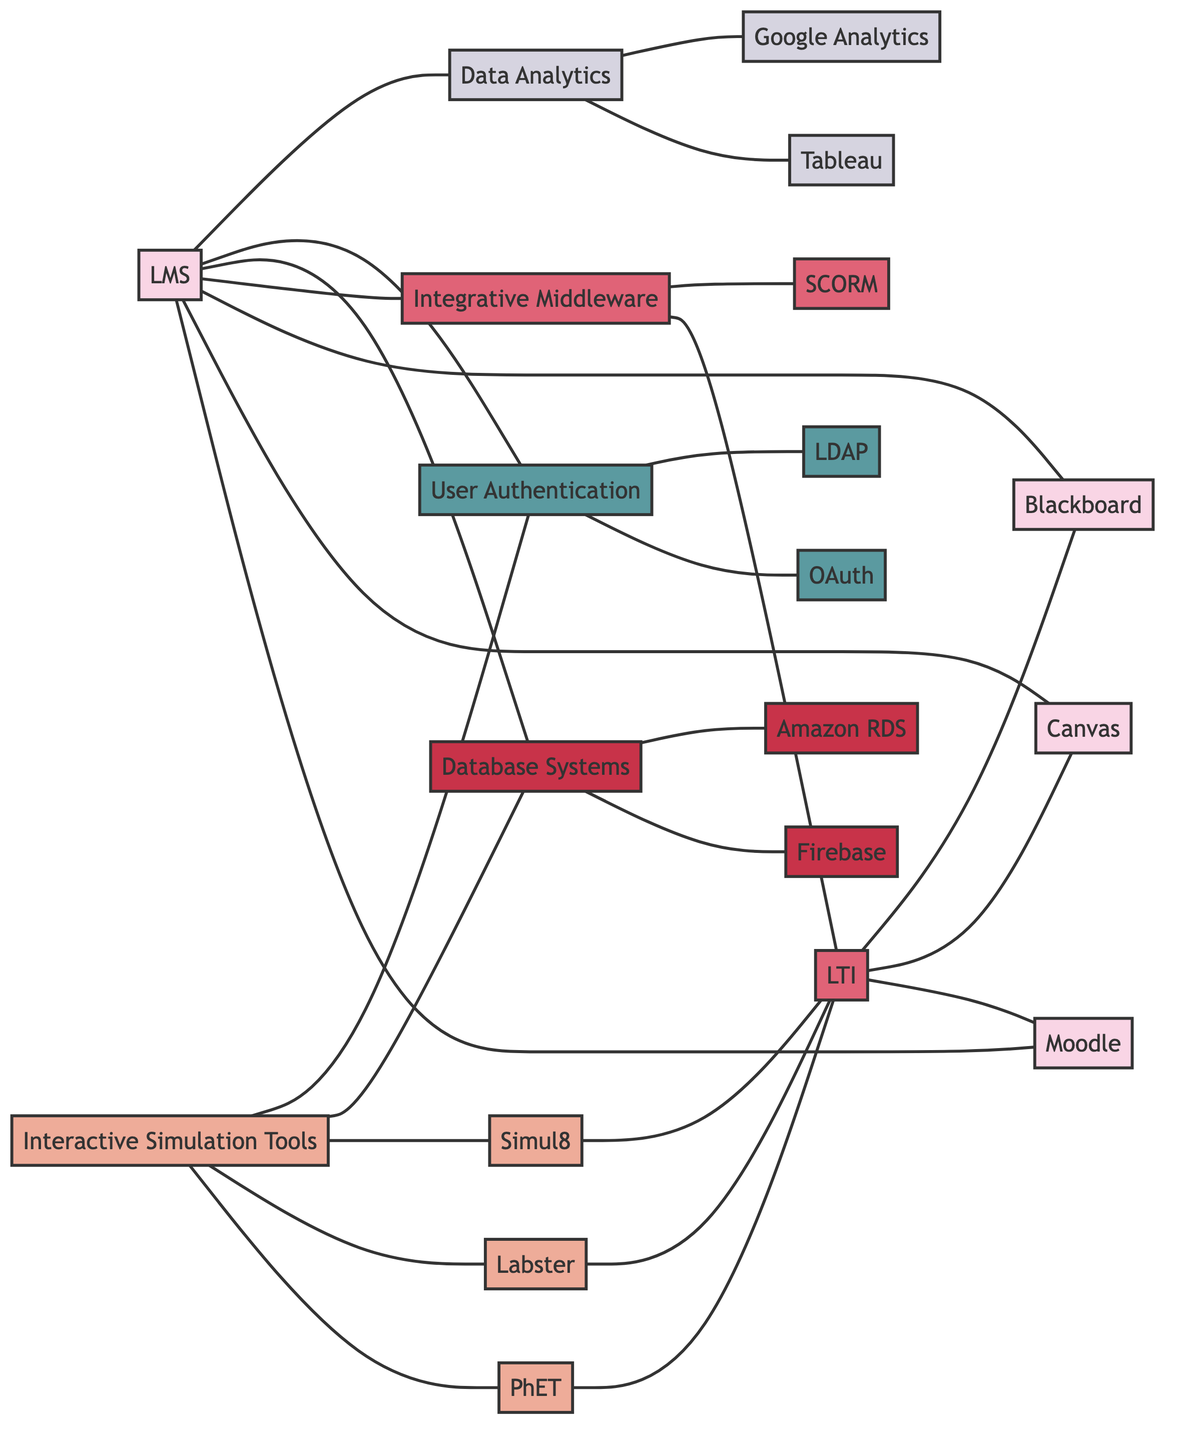What's the total number of nodes in the diagram? Counting all distinct entities represented as nodes in the diagram, we identify a total of 20 nodes.
Answer: 20 Which LMS is not connected to Integrative Middleware? By observing the connections from the LMS nodes, Moodle, Canvas, and Blackboard are all connected to Integrative Middleware, but there is no direct connection shown between Integrative Middleware and other potential LMS systems.
Answer: None How many Interactive Simulation Tools are connected to LTI? The Interactive Simulation Tools connected to LTI according to the diagram are PhET Simulations, Labster, and Simul8. There are three connections to LTI.
Answer: 3 What type of system does the edge between Database Systems and Firebase represent? The edge shows that Database Systems have a direct connection to Firebase, indicating Firebase is a section of or function related to the Database System node.
Answer: Database What is the primary purpose of the Integrative Middleware node? Integrative Middleware serves to connect various systems and tools, specifically allowing interoperability between Learning Tools and the LMS. The edges connected to LTI and SCORM further support this role.
Answer: Interoperability Which authentication system is connected to the LMS? The User Authentication Platforms are connected to LMS, which indicates their use for securing and managing user login and identity functions relative to the Learning Management System.
Answer: User Authentication Platforms Are there more data analytics tools or user authentication platforms connected to the LMS? Upon assessing the connections, there are two data analytics tools (Tableau, Google Analytics) compared to two user authentication platforms (OAuth, LDAP). Therefore, they are equal in number.
Answer: Equal What connects the Interactive Simulation Tools to the Database Systems? The edge existing between the Interactive Simulation Tools and Database Systems indicates that the simulations can store or retrieve data, highlighting their function in utilizing databases for operational support.
Answer: Data management How many edges connect LMS to other systems? By counting all lines (edges) connected to the LMS node, we find it connects directly to Moodle, Canvas, Blackboard, Integrative Middleware, Database Systems, User Authentication Platforms, and Data Analytics Tools, totaling seven edges.
Answer: 7 